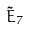<formula> <loc_0><loc_0><loc_500><loc_500>\tilde { E } _ { 7 }</formula> 